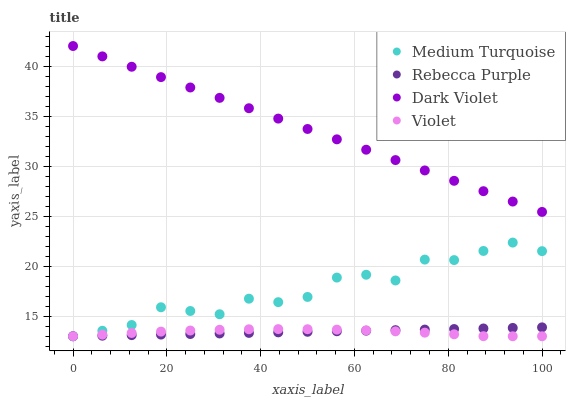Does Violet have the minimum area under the curve?
Answer yes or no. Yes. Does Dark Violet have the maximum area under the curve?
Answer yes or no. Yes. Does Rebecca Purple have the minimum area under the curve?
Answer yes or no. No. Does Rebecca Purple have the maximum area under the curve?
Answer yes or no. No. Is Rebecca Purple the smoothest?
Answer yes or no. Yes. Is Medium Turquoise the roughest?
Answer yes or no. Yes. Is Medium Turquoise the smoothest?
Answer yes or no. No. Is Rebecca Purple the roughest?
Answer yes or no. No. Does Rebecca Purple have the lowest value?
Answer yes or no. Yes. Does Dark Violet have the highest value?
Answer yes or no. Yes. Does Rebecca Purple have the highest value?
Answer yes or no. No. Is Violet less than Dark Violet?
Answer yes or no. Yes. Is Dark Violet greater than Violet?
Answer yes or no. Yes. Does Violet intersect Rebecca Purple?
Answer yes or no. Yes. Is Violet less than Rebecca Purple?
Answer yes or no. No. Is Violet greater than Rebecca Purple?
Answer yes or no. No. Does Violet intersect Dark Violet?
Answer yes or no. No. 